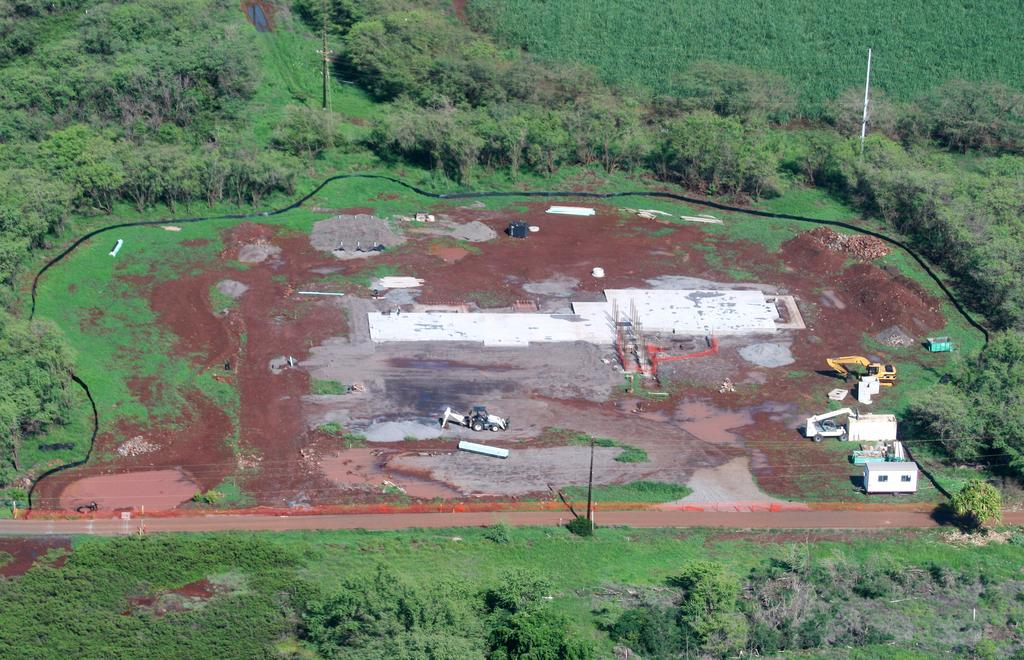What types of vehicles are in the image? There are vehicles in the image, but the specific types are not mentioned. What else can be seen in the image besides vehicles? There are poles, cables, other objects, and trees in the background of the image. What might the poles and cables be used for? The poles and cables might be used for supporting or transmitting power or communication lines. Can you describe the background of the image? The background of the image includes trees. What type of worm can be seen crawling on the father's shoulder in the image? There is no father or worm present in the image. 